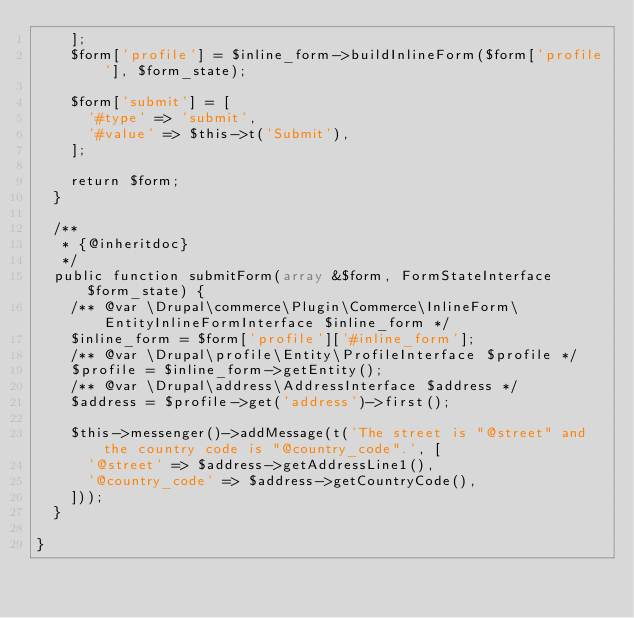Convert code to text. <code><loc_0><loc_0><loc_500><loc_500><_PHP_>    ];
    $form['profile'] = $inline_form->buildInlineForm($form['profile'], $form_state);

    $form['submit'] = [
      '#type' => 'submit',
      '#value' => $this->t('Submit'),
    ];

    return $form;
  }

  /**
   * {@inheritdoc}
   */
  public function submitForm(array &$form, FormStateInterface $form_state) {
    /** @var \Drupal\commerce\Plugin\Commerce\InlineForm\EntityInlineFormInterface $inline_form */
    $inline_form = $form['profile']['#inline_form'];
    /** @var \Drupal\profile\Entity\ProfileInterface $profile */
    $profile = $inline_form->getEntity();
    /** @var \Drupal\address\AddressInterface $address */
    $address = $profile->get('address')->first();

    $this->messenger()->addMessage(t('The street is "@street" and the country code is "@country_code".', [
      '@street' => $address->getAddressLine1(),
      '@country_code' => $address->getCountryCode(),
    ]));
  }

}
</code> 